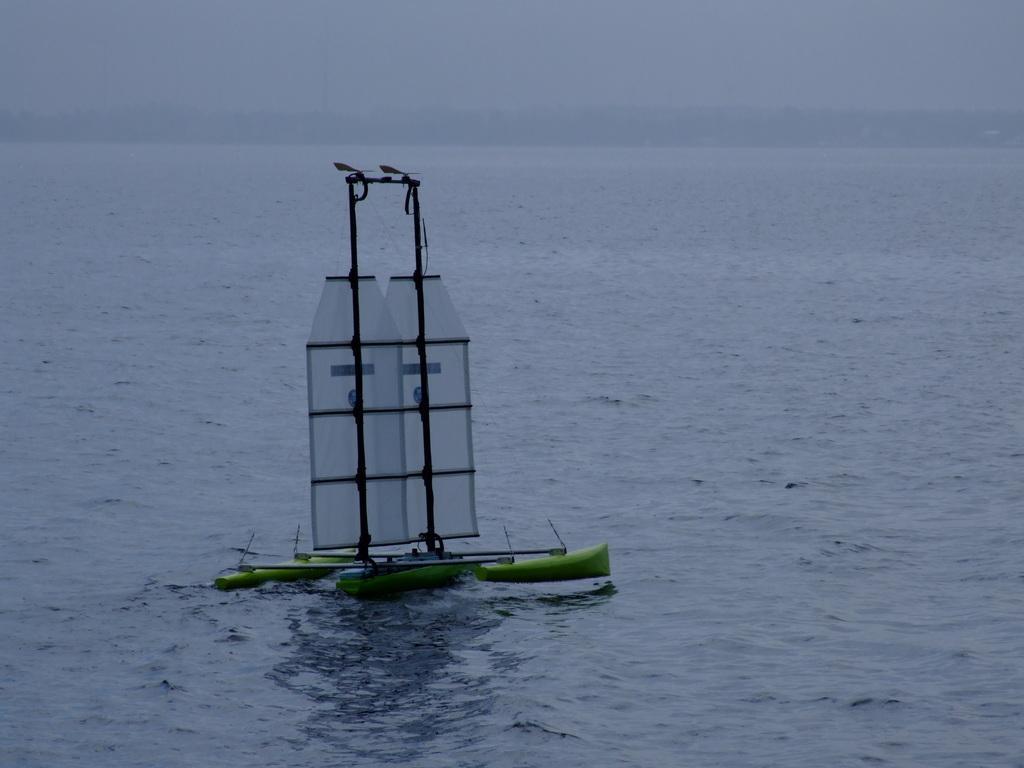In one or two sentences, can you explain what this image depicts? In the middle of the picture, it looks like a boat. We see the boat is sailing on the water. At the bottom, we see water and this water might be in the sea. In the background, it looks like the hills. At the top, we see the sky. 